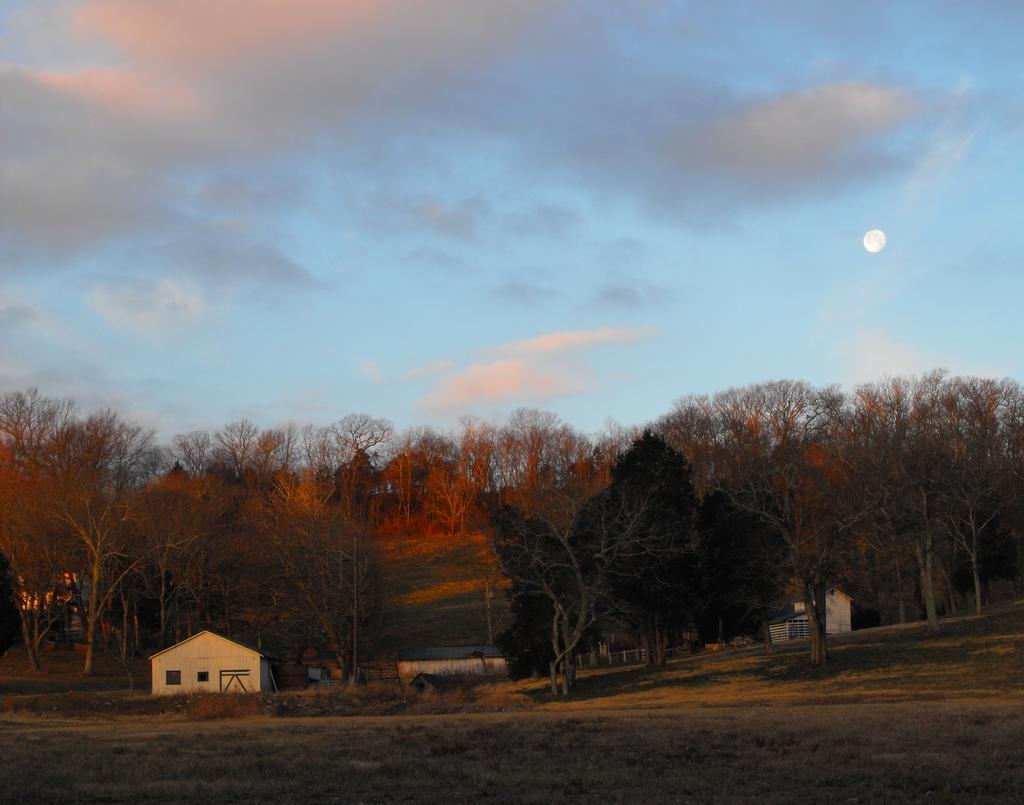Describe this image in one or two sentences. In this image in the background there are trees, there is a house and there are objects which are white in colour and the sky is cloudy and there is a moon visible in the sky. 